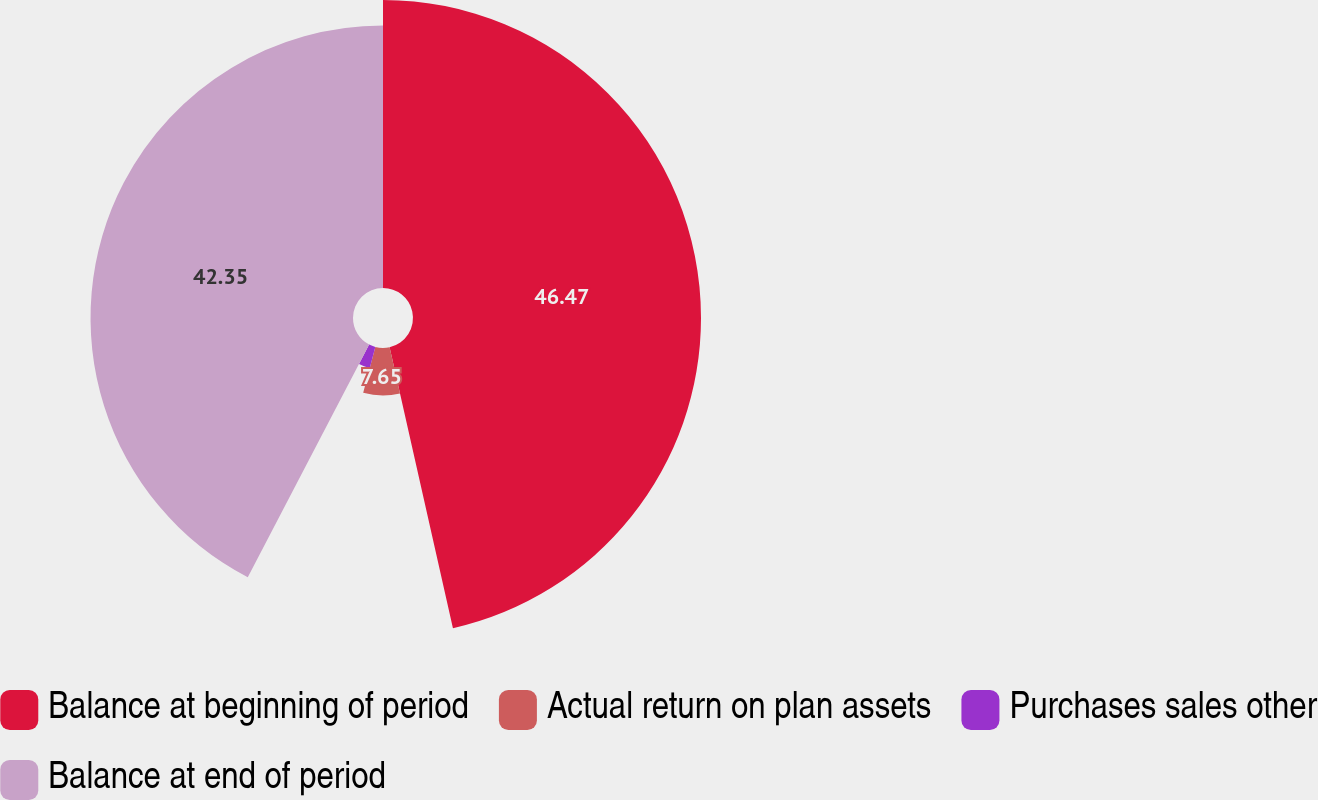Convert chart. <chart><loc_0><loc_0><loc_500><loc_500><pie_chart><fcel>Balance at beginning of period<fcel>Actual return on plan assets<fcel>Purchases sales other<fcel>Balance at end of period<nl><fcel>46.47%<fcel>7.65%<fcel>3.53%<fcel>42.35%<nl></chart> 